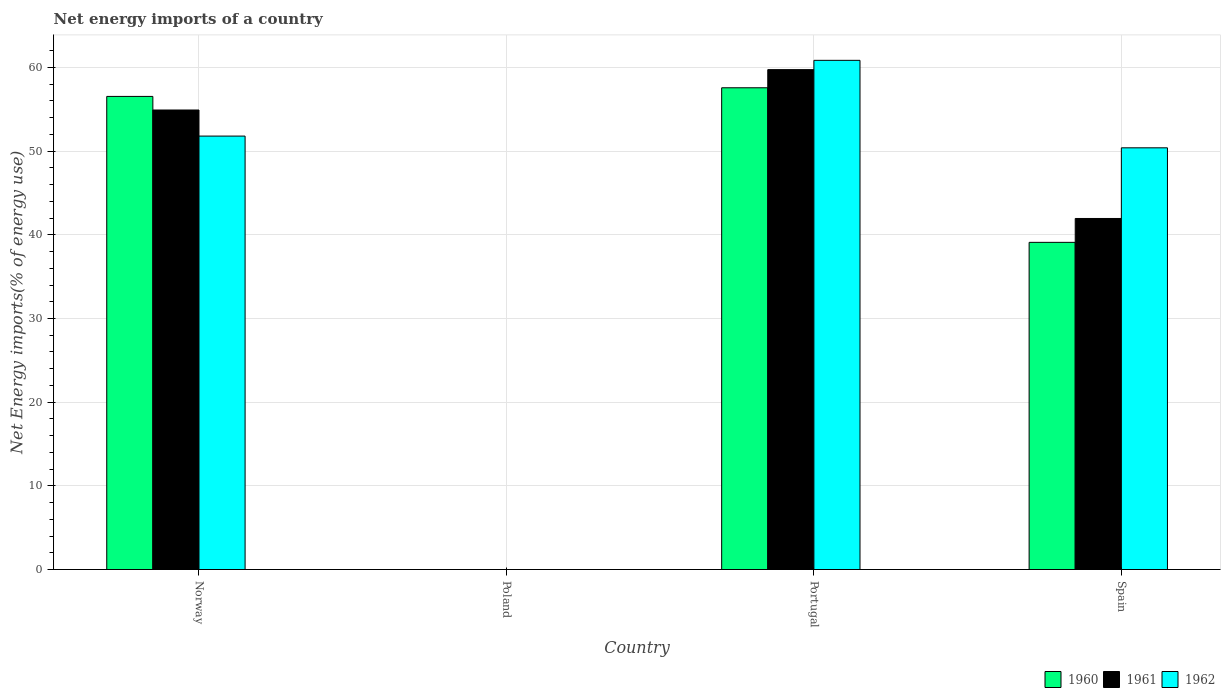Are the number of bars per tick equal to the number of legend labels?
Ensure brevity in your answer.  No. How many bars are there on the 3rd tick from the left?
Ensure brevity in your answer.  3. What is the label of the 3rd group of bars from the left?
Offer a very short reply. Portugal. What is the net energy imports in 1961 in Spain?
Your answer should be very brief. 41.95. Across all countries, what is the maximum net energy imports in 1960?
Make the answer very short. 57.57. Across all countries, what is the minimum net energy imports in 1962?
Offer a terse response. 0. What is the total net energy imports in 1961 in the graph?
Offer a terse response. 156.61. What is the difference between the net energy imports in 1960 in Portugal and that in Spain?
Make the answer very short. 18.47. What is the difference between the net energy imports in 1962 in Norway and the net energy imports in 1961 in Poland?
Make the answer very short. 51.8. What is the average net energy imports in 1962 per country?
Provide a short and direct response. 40.76. What is the difference between the net energy imports of/in 1961 and net energy imports of/in 1960 in Norway?
Provide a short and direct response. -1.62. In how many countries, is the net energy imports in 1960 greater than 40 %?
Offer a very short reply. 2. What is the ratio of the net energy imports in 1962 in Portugal to that in Spain?
Make the answer very short. 1.21. What is the difference between the highest and the second highest net energy imports in 1960?
Offer a terse response. -1.03. What is the difference between the highest and the lowest net energy imports in 1962?
Your response must be concise. 60.85. Is the sum of the net energy imports in 1961 in Norway and Portugal greater than the maximum net energy imports in 1960 across all countries?
Offer a terse response. Yes. How many bars are there?
Provide a succinct answer. 9. Are all the bars in the graph horizontal?
Offer a terse response. No. How many countries are there in the graph?
Offer a very short reply. 4. What is the difference between two consecutive major ticks on the Y-axis?
Keep it short and to the point. 10. Does the graph contain any zero values?
Provide a short and direct response. Yes. Does the graph contain grids?
Your answer should be very brief. Yes. Where does the legend appear in the graph?
Offer a terse response. Bottom right. How many legend labels are there?
Your answer should be compact. 3. What is the title of the graph?
Ensure brevity in your answer.  Net energy imports of a country. What is the label or title of the Y-axis?
Keep it short and to the point. Net Energy imports(% of energy use). What is the Net Energy imports(% of energy use) of 1960 in Norway?
Your response must be concise. 56.54. What is the Net Energy imports(% of energy use) in 1961 in Norway?
Your response must be concise. 54.92. What is the Net Energy imports(% of energy use) of 1962 in Norway?
Your answer should be very brief. 51.8. What is the Net Energy imports(% of energy use) in 1960 in Poland?
Give a very brief answer. 0. What is the Net Energy imports(% of energy use) of 1960 in Portugal?
Offer a terse response. 57.57. What is the Net Energy imports(% of energy use) in 1961 in Portugal?
Give a very brief answer. 59.74. What is the Net Energy imports(% of energy use) of 1962 in Portugal?
Keep it short and to the point. 60.85. What is the Net Energy imports(% of energy use) in 1960 in Spain?
Your answer should be very brief. 39.1. What is the Net Energy imports(% of energy use) of 1961 in Spain?
Ensure brevity in your answer.  41.95. What is the Net Energy imports(% of energy use) of 1962 in Spain?
Offer a terse response. 50.4. Across all countries, what is the maximum Net Energy imports(% of energy use) of 1960?
Keep it short and to the point. 57.57. Across all countries, what is the maximum Net Energy imports(% of energy use) of 1961?
Keep it short and to the point. 59.74. Across all countries, what is the maximum Net Energy imports(% of energy use) in 1962?
Provide a succinct answer. 60.85. Across all countries, what is the minimum Net Energy imports(% of energy use) in 1961?
Your answer should be compact. 0. Across all countries, what is the minimum Net Energy imports(% of energy use) in 1962?
Keep it short and to the point. 0. What is the total Net Energy imports(% of energy use) of 1960 in the graph?
Ensure brevity in your answer.  153.22. What is the total Net Energy imports(% of energy use) of 1961 in the graph?
Make the answer very short. 156.61. What is the total Net Energy imports(% of energy use) of 1962 in the graph?
Your answer should be compact. 163.05. What is the difference between the Net Energy imports(% of energy use) of 1960 in Norway and that in Portugal?
Your answer should be very brief. -1.03. What is the difference between the Net Energy imports(% of energy use) of 1961 in Norway and that in Portugal?
Provide a short and direct response. -4.83. What is the difference between the Net Energy imports(% of energy use) in 1962 in Norway and that in Portugal?
Your answer should be compact. -9.05. What is the difference between the Net Energy imports(% of energy use) of 1960 in Norway and that in Spain?
Provide a succinct answer. 17.44. What is the difference between the Net Energy imports(% of energy use) of 1961 in Norway and that in Spain?
Your answer should be very brief. 12.96. What is the difference between the Net Energy imports(% of energy use) in 1962 in Norway and that in Spain?
Provide a succinct answer. 1.4. What is the difference between the Net Energy imports(% of energy use) of 1960 in Portugal and that in Spain?
Your response must be concise. 18.47. What is the difference between the Net Energy imports(% of energy use) in 1961 in Portugal and that in Spain?
Provide a succinct answer. 17.79. What is the difference between the Net Energy imports(% of energy use) of 1962 in Portugal and that in Spain?
Provide a short and direct response. 10.46. What is the difference between the Net Energy imports(% of energy use) in 1960 in Norway and the Net Energy imports(% of energy use) in 1961 in Portugal?
Keep it short and to the point. -3.2. What is the difference between the Net Energy imports(% of energy use) of 1960 in Norway and the Net Energy imports(% of energy use) of 1962 in Portugal?
Make the answer very short. -4.31. What is the difference between the Net Energy imports(% of energy use) in 1961 in Norway and the Net Energy imports(% of energy use) in 1962 in Portugal?
Your answer should be very brief. -5.94. What is the difference between the Net Energy imports(% of energy use) in 1960 in Norway and the Net Energy imports(% of energy use) in 1961 in Spain?
Your answer should be very brief. 14.59. What is the difference between the Net Energy imports(% of energy use) of 1960 in Norway and the Net Energy imports(% of energy use) of 1962 in Spain?
Your answer should be compact. 6.14. What is the difference between the Net Energy imports(% of energy use) of 1961 in Norway and the Net Energy imports(% of energy use) of 1962 in Spain?
Your answer should be very brief. 4.52. What is the difference between the Net Energy imports(% of energy use) of 1960 in Portugal and the Net Energy imports(% of energy use) of 1961 in Spain?
Give a very brief answer. 15.62. What is the difference between the Net Energy imports(% of energy use) of 1960 in Portugal and the Net Energy imports(% of energy use) of 1962 in Spain?
Provide a succinct answer. 7.18. What is the difference between the Net Energy imports(% of energy use) of 1961 in Portugal and the Net Energy imports(% of energy use) of 1962 in Spain?
Your answer should be compact. 9.34. What is the average Net Energy imports(% of energy use) of 1960 per country?
Offer a very short reply. 38.3. What is the average Net Energy imports(% of energy use) of 1961 per country?
Your answer should be very brief. 39.15. What is the average Net Energy imports(% of energy use) of 1962 per country?
Make the answer very short. 40.76. What is the difference between the Net Energy imports(% of energy use) of 1960 and Net Energy imports(% of energy use) of 1961 in Norway?
Give a very brief answer. 1.62. What is the difference between the Net Energy imports(% of energy use) in 1960 and Net Energy imports(% of energy use) in 1962 in Norway?
Make the answer very short. 4.74. What is the difference between the Net Energy imports(% of energy use) of 1961 and Net Energy imports(% of energy use) of 1962 in Norway?
Your answer should be compact. 3.12. What is the difference between the Net Energy imports(% of energy use) in 1960 and Net Energy imports(% of energy use) in 1961 in Portugal?
Your answer should be very brief. -2.17. What is the difference between the Net Energy imports(% of energy use) of 1960 and Net Energy imports(% of energy use) of 1962 in Portugal?
Ensure brevity in your answer.  -3.28. What is the difference between the Net Energy imports(% of energy use) in 1961 and Net Energy imports(% of energy use) in 1962 in Portugal?
Give a very brief answer. -1.11. What is the difference between the Net Energy imports(% of energy use) in 1960 and Net Energy imports(% of energy use) in 1961 in Spain?
Your answer should be very brief. -2.85. What is the difference between the Net Energy imports(% of energy use) in 1960 and Net Energy imports(% of energy use) in 1962 in Spain?
Provide a short and direct response. -11.3. What is the difference between the Net Energy imports(% of energy use) in 1961 and Net Energy imports(% of energy use) in 1962 in Spain?
Your answer should be very brief. -8.44. What is the ratio of the Net Energy imports(% of energy use) of 1960 in Norway to that in Portugal?
Offer a terse response. 0.98. What is the ratio of the Net Energy imports(% of energy use) of 1961 in Norway to that in Portugal?
Your answer should be very brief. 0.92. What is the ratio of the Net Energy imports(% of energy use) of 1962 in Norway to that in Portugal?
Offer a very short reply. 0.85. What is the ratio of the Net Energy imports(% of energy use) of 1960 in Norway to that in Spain?
Ensure brevity in your answer.  1.45. What is the ratio of the Net Energy imports(% of energy use) of 1961 in Norway to that in Spain?
Make the answer very short. 1.31. What is the ratio of the Net Energy imports(% of energy use) of 1962 in Norway to that in Spain?
Your answer should be compact. 1.03. What is the ratio of the Net Energy imports(% of energy use) in 1960 in Portugal to that in Spain?
Your answer should be very brief. 1.47. What is the ratio of the Net Energy imports(% of energy use) of 1961 in Portugal to that in Spain?
Offer a terse response. 1.42. What is the ratio of the Net Energy imports(% of energy use) of 1962 in Portugal to that in Spain?
Offer a very short reply. 1.21. What is the difference between the highest and the second highest Net Energy imports(% of energy use) in 1960?
Keep it short and to the point. 1.03. What is the difference between the highest and the second highest Net Energy imports(% of energy use) in 1961?
Offer a very short reply. 4.83. What is the difference between the highest and the second highest Net Energy imports(% of energy use) of 1962?
Provide a short and direct response. 9.05. What is the difference between the highest and the lowest Net Energy imports(% of energy use) in 1960?
Make the answer very short. 57.57. What is the difference between the highest and the lowest Net Energy imports(% of energy use) in 1961?
Your response must be concise. 59.74. What is the difference between the highest and the lowest Net Energy imports(% of energy use) of 1962?
Provide a succinct answer. 60.85. 